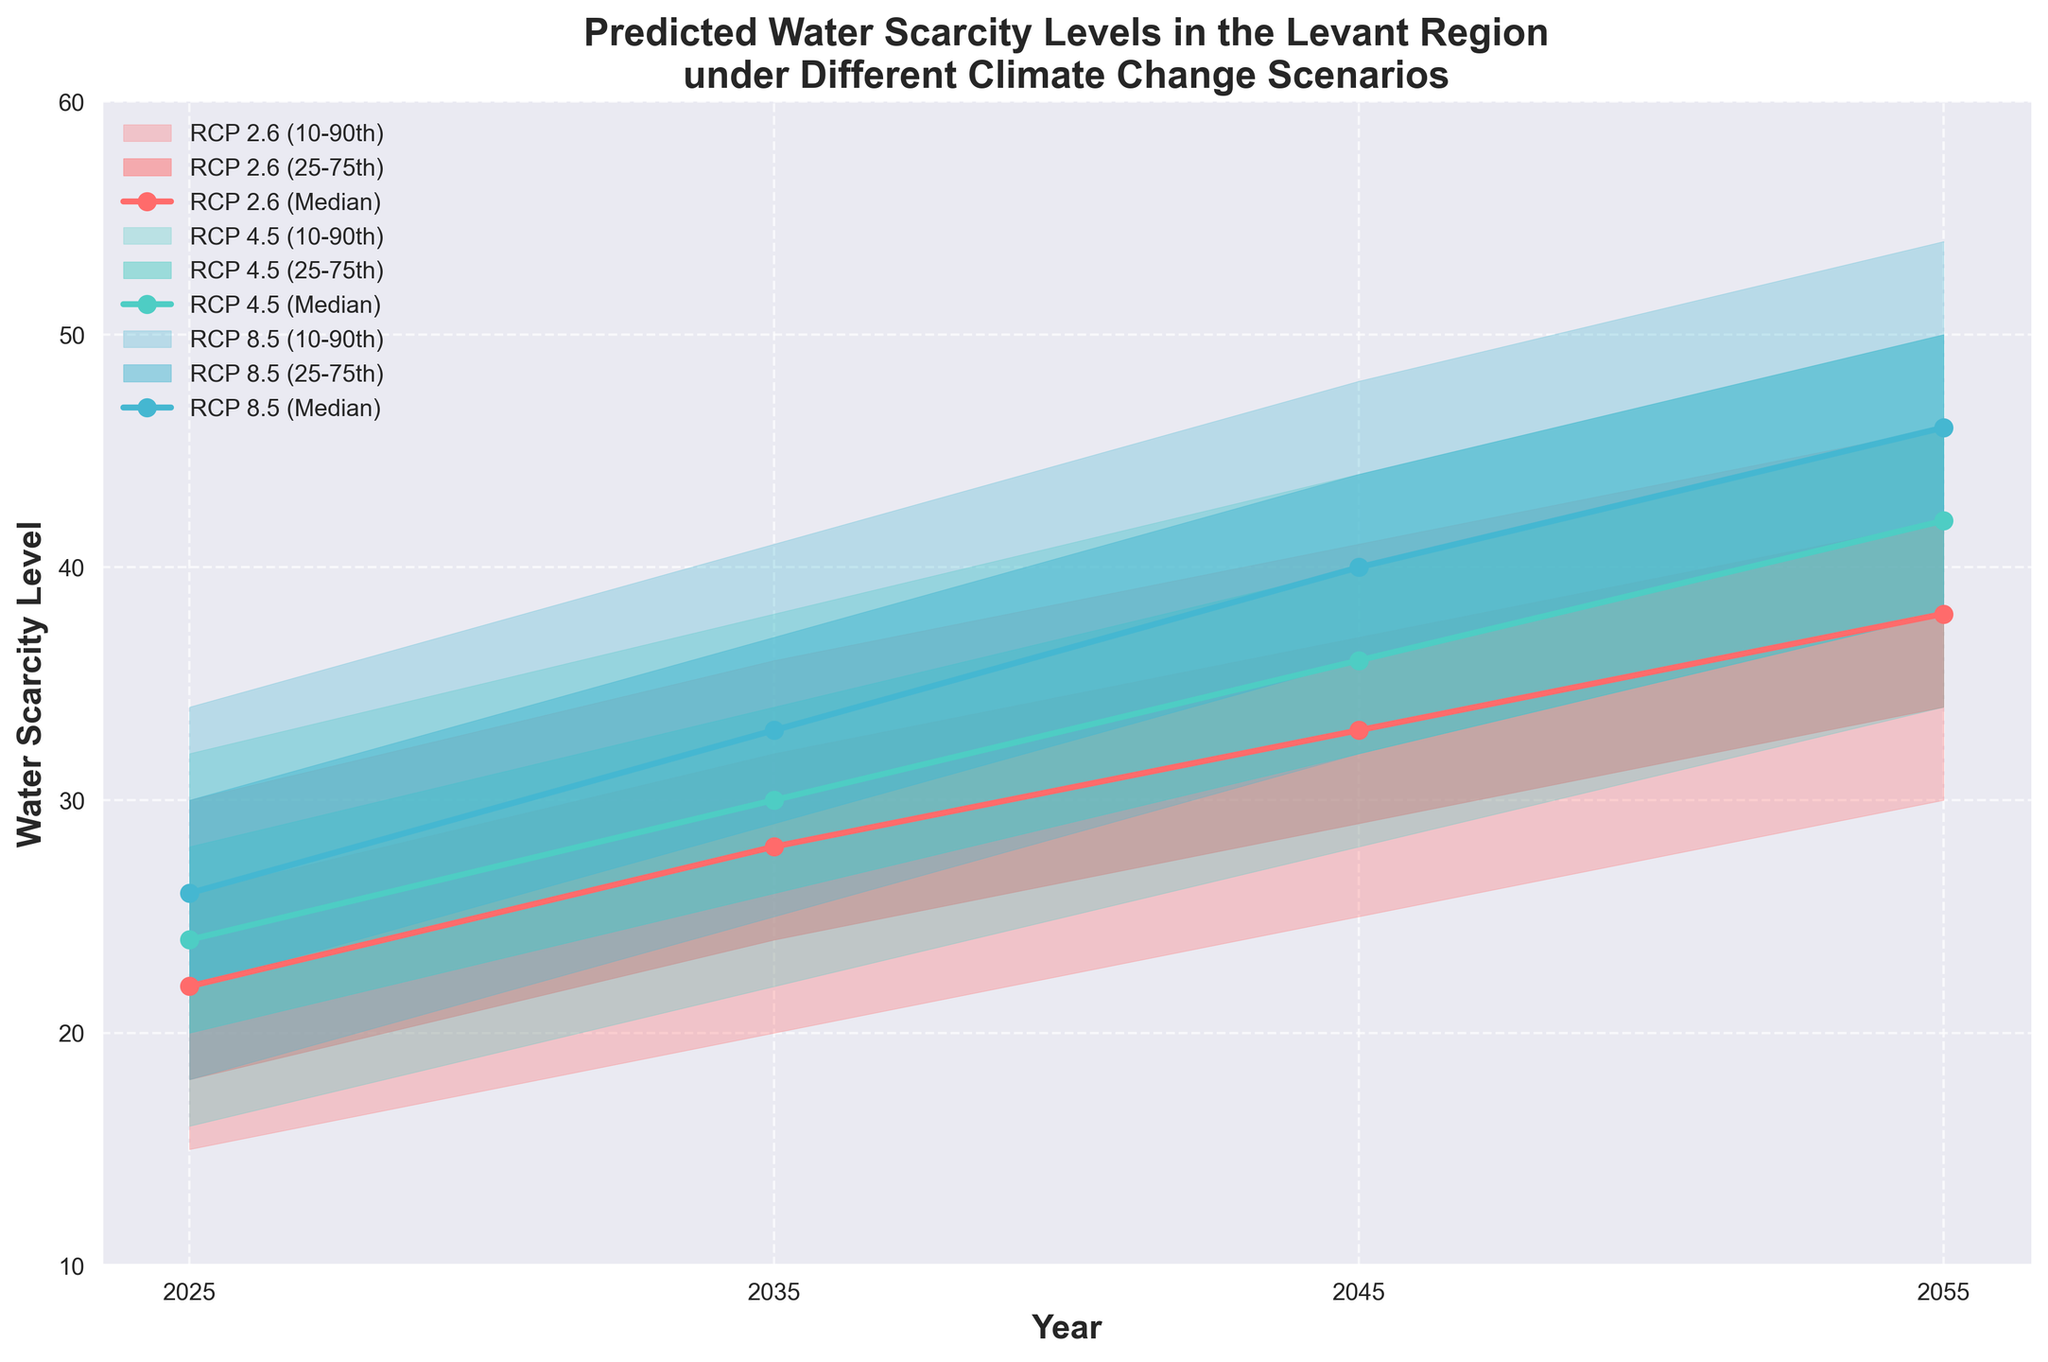What is the title of the figure? The title is usually displayed at the top of the figure. From the description, it should summarize the content of the plot.
Answer: Predicted Water Scarcity Levels in the Levant Region under Different Climate Change Scenarios What are the years shown on the x-axis? The x-axis represents time. By looking at the ticks or labels, we can determine the years included in the plot.
Answer: 2025, 2035, 2045, 2055 What climate change scenarios are included in the figure? The different scenarios can be identified by looking at the legend or the labels. Based on the described data, we can identify three scenarios.
Answer: RCP 2.6, RCP 4.5, RCP 8.5 Which scenario predicts the highest median water scarcity level in 2055? By identifying the median values for each scenario in 2055, we can compare them to find the highest one.
Answer: RCP 8.5 How does the median water scarcity level for RCP 2.6 change from 2025 to 2055? We look at the median values for RCP 2.6 in 2025 and 2055 and find the difference. For 2025, it is 22, and for 2055, it is 38.
Answer: Increases by 16 Which year shows the greatest variability in predicted water scarcity levels for RCP 4.5? Variability can be measured by the range between the 10th and 90th percentiles for each year under RCP 4.5.
Answer: 2055 (range of 16) What is the approximate range of predicted water scarcity levels for RCP 8.5 in 2045? The range is found by subtracting the 10th percentile from the 90th percentile. For RCP 8.5 in 2045, it is from 32 to 48.
Answer: 16 units Which percentile bands are narrower across all scenarios and years, the 25th-75th or the 10th-90th? By comparing the widths of the two shaded percentile bands at each year, we can find that the 25th-75th percentiles are consistently narrower.
Answer: 25th-75th What general trend is observed in the median water scarcity levels across all scenarios from 2025 to 2055? The general trend can be identified by looking at the median values across the years for each scenario.
Answer: Increasing trend in median levels 